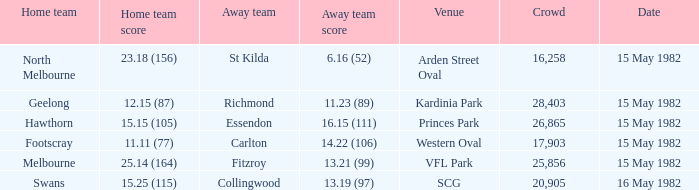Where did North Melbourne play as the home team? Arden Street Oval. 